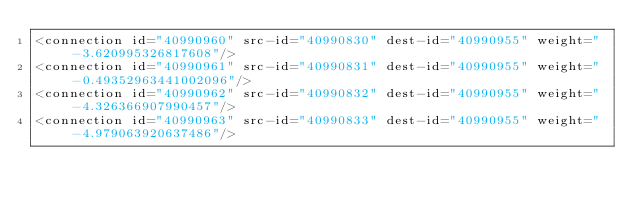Convert code to text. <code><loc_0><loc_0><loc_500><loc_500><_XML_><connection id="40990960" src-id="40990830" dest-id="40990955" weight="-3.620995326817608"/>
<connection id="40990961" src-id="40990831" dest-id="40990955" weight="-0.49352963441002096"/>
<connection id="40990962" src-id="40990832" dest-id="40990955" weight="-4.326366907990457"/>
<connection id="40990963" src-id="40990833" dest-id="40990955" weight="-4.979063920637486"/></code> 